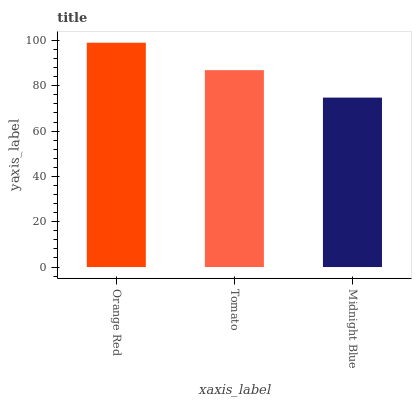Is Midnight Blue the minimum?
Answer yes or no. Yes. Is Orange Red the maximum?
Answer yes or no. Yes. Is Tomato the minimum?
Answer yes or no. No. Is Tomato the maximum?
Answer yes or no. No. Is Orange Red greater than Tomato?
Answer yes or no. Yes. Is Tomato less than Orange Red?
Answer yes or no. Yes. Is Tomato greater than Orange Red?
Answer yes or no. No. Is Orange Red less than Tomato?
Answer yes or no. No. Is Tomato the high median?
Answer yes or no. Yes. Is Tomato the low median?
Answer yes or no. Yes. Is Midnight Blue the high median?
Answer yes or no. No. Is Midnight Blue the low median?
Answer yes or no. No. 